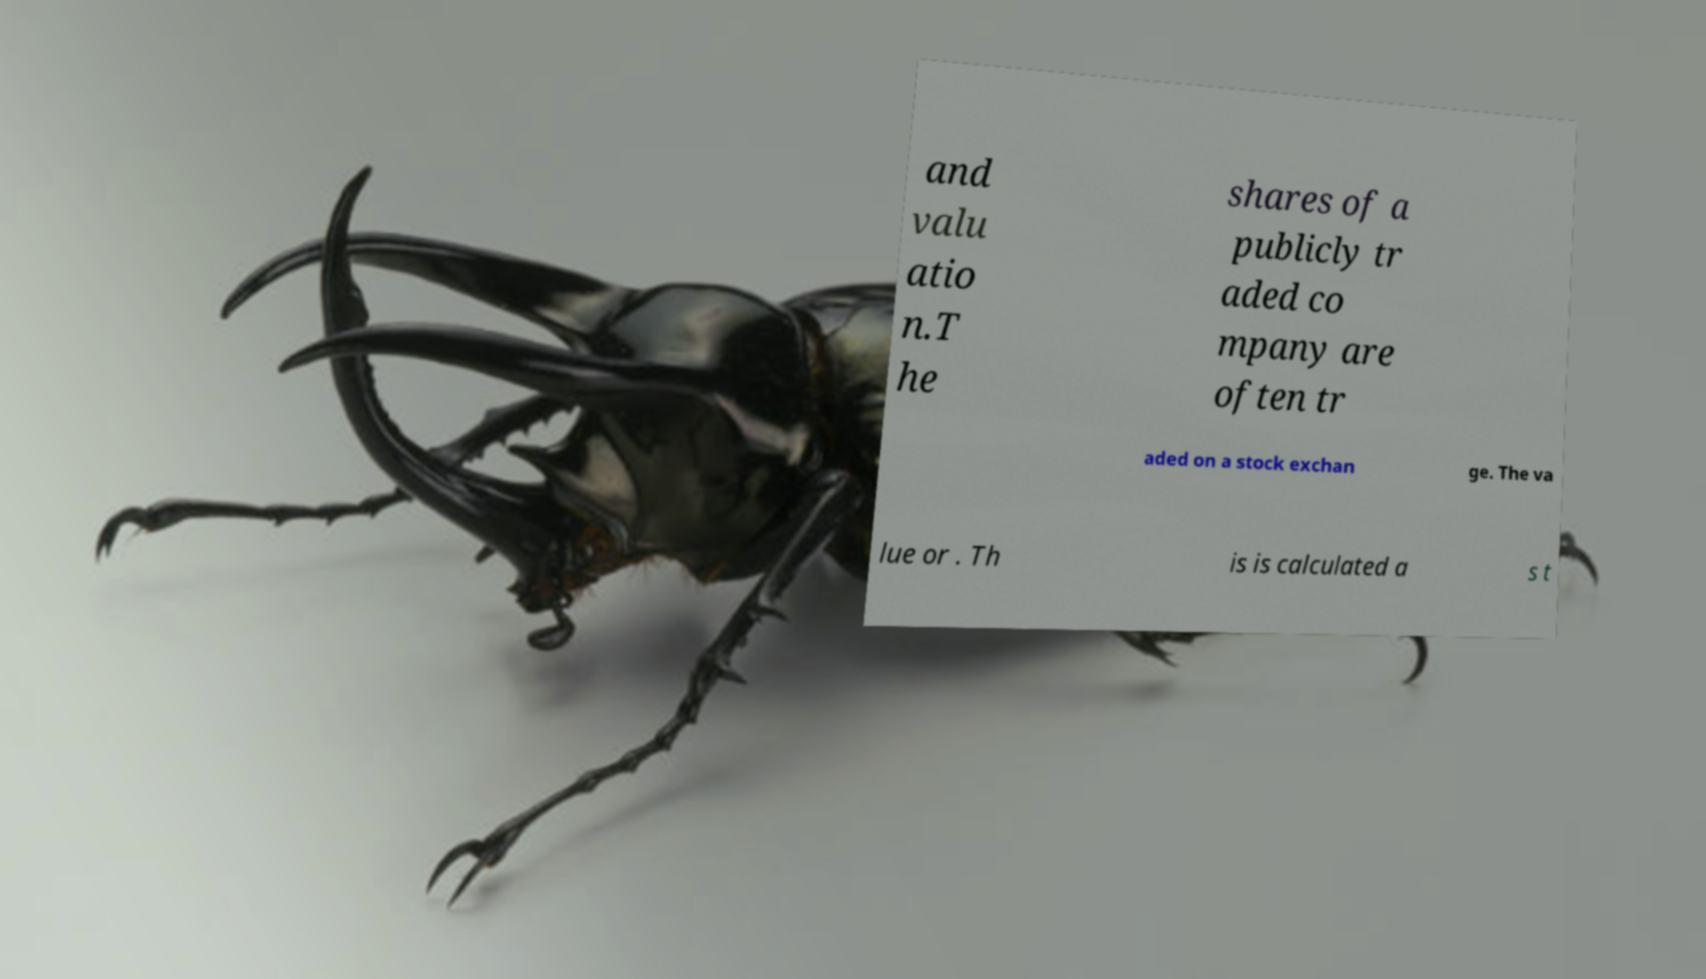For documentation purposes, I need the text within this image transcribed. Could you provide that? and valu atio n.T he shares of a publicly tr aded co mpany are often tr aded on a stock exchan ge. The va lue or . Th is is calculated a s t 